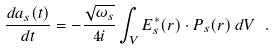<formula> <loc_0><loc_0><loc_500><loc_500>\frac { d a _ { s } ( t ) } { d t } = - \frac { \sqrt { \omega _ { s } } } { 4 i } \int _ { V } E _ { s } ^ { * } ( r ) \cdot P _ { s } ( r ) \, d V \ .</formula> 